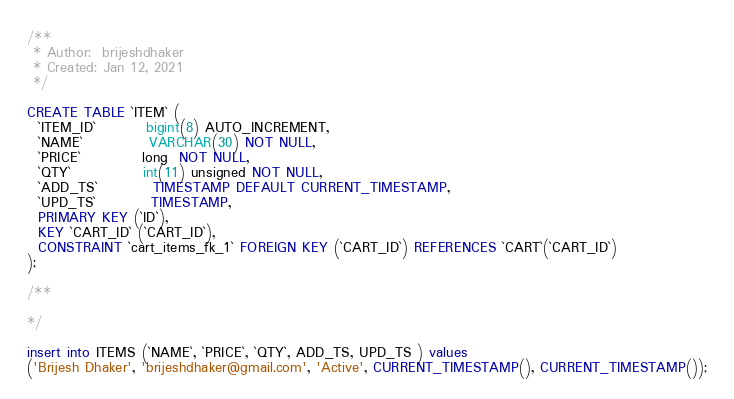<code> <loc_0><loc_0><loc_500><loc_500><_SQL_>/**
 * Author:  brijeshdhaker
 * Created: Jan 12, 2021
 */

CREATE TABLE `ITEM` (
  `ITEM_ID`         bigint(8) AUTO_INCREMENT,
  `NAME`            VARCHAR(30) NOT NULL,
  `PRICE`           long  NOT NULL,
  `QTY`             int(11) unsigned NOT NULL,
  `ADD_TS`          TIMESTAMP DEFAULT CURRENT_TIMESTAMP,
  `UPD_TS`          TIMESTAMP,
  PRIMARY KEY (`ID`),
  KEY `CART_ID` (`CART_ID`),
  CONSTRAINT `cart_items_fk_1` FOREIGN KEY (`CART_ID`) REFERENCES `CART`(`CART_ID`)
);

/**

*/

insert into ITEMS (`NAME`, `PRICE`, `QTY`, ADD_TS, UPD_TS ) values
('Brijesh Dhaker', 'brijeshdhaker@gmail.com', 'Active', CURRENT_TIMESTAMP(), CURRENT_TIMESTAMP());
</code> 